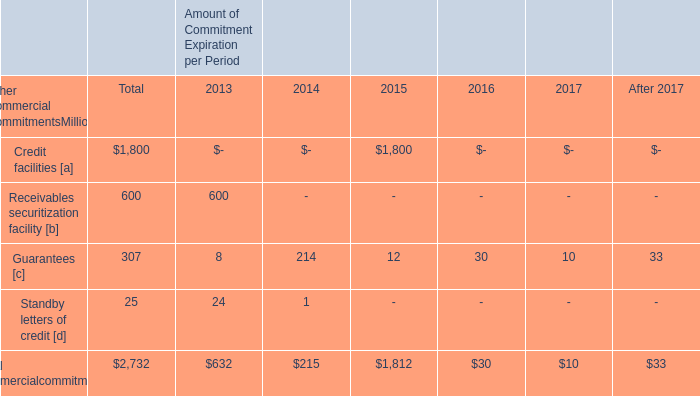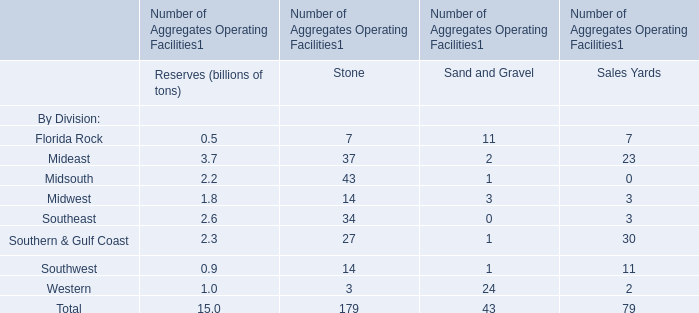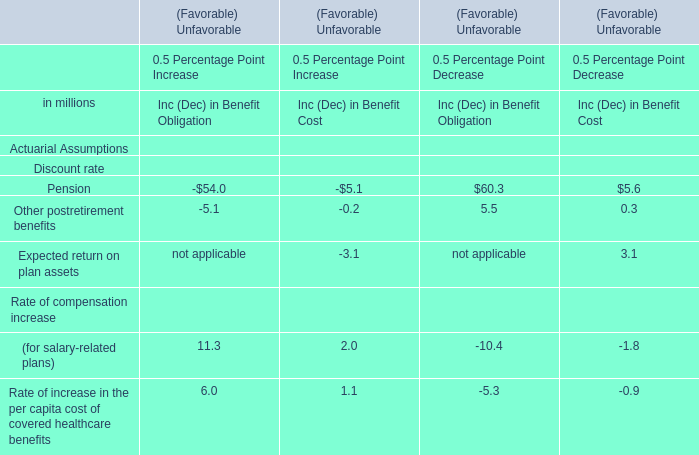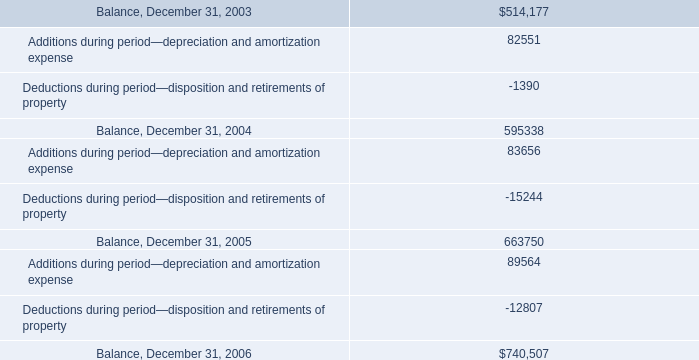In which section the sum of Mideast has the highest value? 
Answer: Stone. 